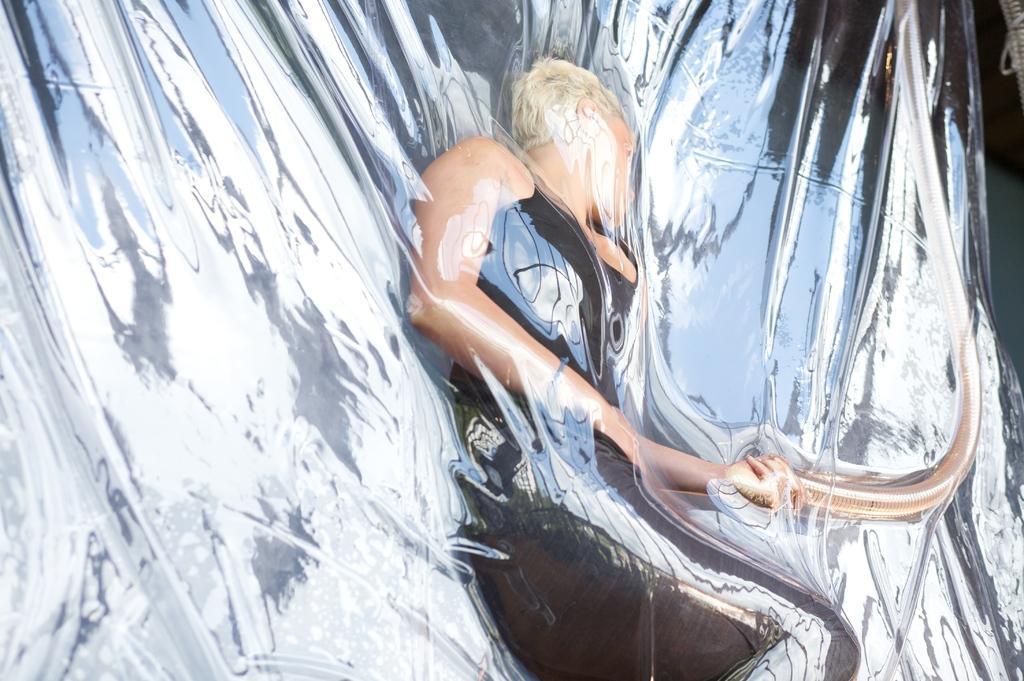Could you give a brief overview of what you see in this image? There is a person wearing black color clothes. 